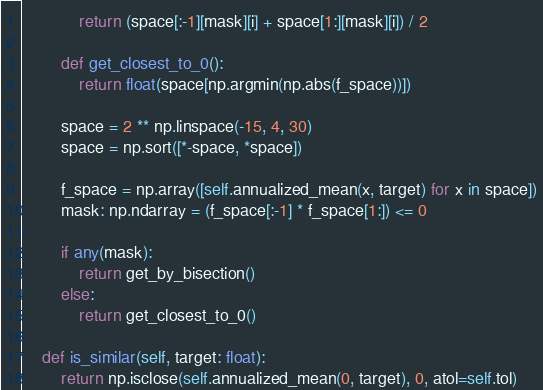<code> <loc_0><loc_0><loc_500><loc_500><_Python_>            return (space[:-1][mask][i] + space[1:][mask][i]) / 2

        def get_closest_to_0():
            return float(space[np.argmin(np.abs(f_space))])

        space = 2 ** np.linspace(-15, 4, 30)
        space = np.sort([*-space, *space])

        f_space = np.array([self.annualized_mean(x, target) for x in space])
        mask: np.ndarray = (f_space[:-1] * f_space[1:]) <= 0

        if any(mask):
            return get_by_bisection()
        else:
            return get_closest_to_0()

    def is_similar(self, target: float):
        return np.isclose(self.annualized_mean(0, target), 0, atol=self.tol)
</code> 